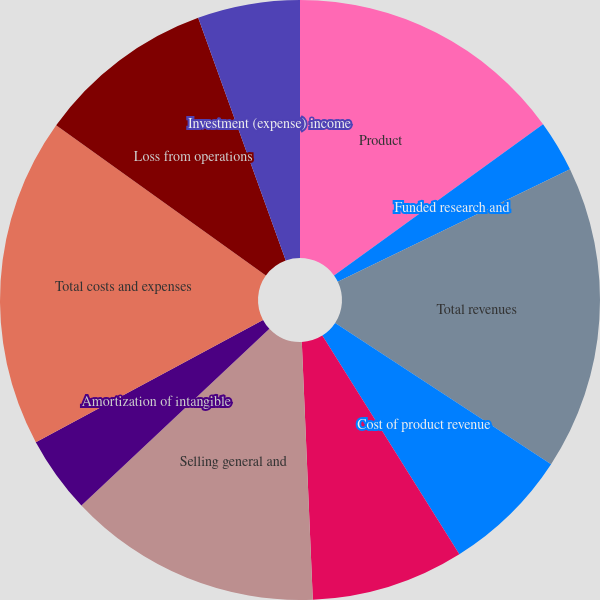Convert chart to OTSL. <chart><loc_0><loc_0><loc_500><loc_500><pie_chart><fcel>Product<fcel>Funded research and<fcel>Total revenues<fcel>Cost of product revenue<fcel>Research and development<fcel>Selling general and<fcel>Amortization of intangible<fcel>Total costs and expenses<fcel>Loss from operations<fcel>Investment (expense) income<nl><fcel>15.03%<fcel>2.79%<fcel>16.39%<fcel>6.87%<fcel>8.23%<fcel>13.67%<fcel>4.15%<fcel>17.75%<fcel>9.59%<fcel>5.51%<nl></chart> 